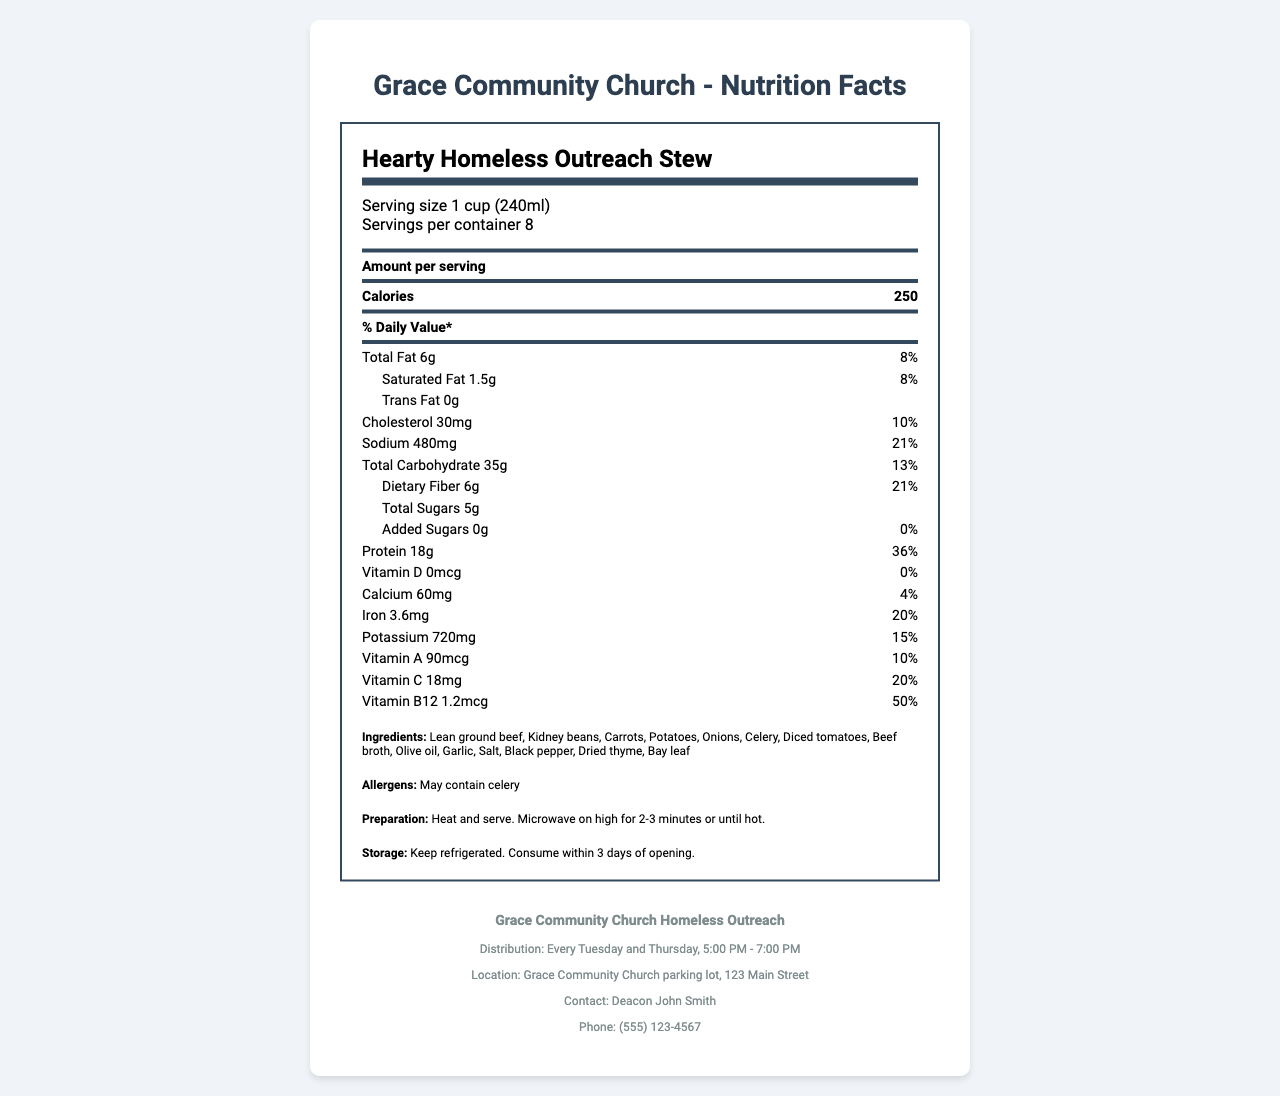how many servings are there per container? The serving info in the document states that there are 8 servings per container.
Answer: 8 what is the calorie content per serving? The document lists the calorie content of each serving as 250 calories.
Answer: 250 calories what percentage of daily value for protein is provided per serving? The document specifies that each serving provides 36% of the daily value for protein.
Answer: 36% how much dietary fiber is in each serving? The document states that each serving contains 6 grams of dietary fiber.
Answer: 6g what vitamins are prominently mentioned in the meal’s nutrient profile? The document highlights vitamins A, C, and B12 with their amounts and daily value percentages.
Answer: Vitamins A, C, and B12 how much cholesterol is in each serving? The document shows that there are 30 milligrams of cholesterol per serving.
Answer: 30mg which ingredient is specifically mentioned as a potential allergen? A. Garlic B. Celery C. Olive oil D. Carrots The allergens section of the document mentions that the meal may contain celery.
Answer: B. Celery when is the meal distribution for the outreach program? A. Monday and Wednesday B. Tuesday and Thursday C. Friday and Sunday The distribution schedule in the outreach program details section is every Tuesday and Thursday.
Answer: B. Tuesday and Thursday is the sodium content considered low for this meal? The sodium content is 480 mg per serving, which is 21% of the daily value, not considered low.
Answer: No does this meal include any added sugars? The document indicates that there are 0 grams of added sugars in the meal.
Answer: No summarize the nutritional benefits of the Hearty Homeless Outreach Stew and its intended purpose. This summary covers the key nutritional benefits, the ingredient choices, and the purpose behind creating the meal for individuals experiencing homelessness.
Answer: The Hearty Homeless Outreach Stew is designed to provide essential nutrients for individuals experiencing homelessness. It is high in protein (18g per serving, 36% daily value), dietary fiber (6g per serving, 21% daily value), and vitamins & minerals such as iron (20% DV), vitamin C (20% DV), and vitamin B12 (50% DV). Lean ground beef and kidney beans ensure good protein content, while a variety of vegetables contribute to the vitamin and mineral profile. The sodium content is managed to maintain a heart-healthy profile while ensuring palatability. what are the specific amounts listed for total sugars and added sugars? The document lists 5 grams of total sugars and 0 grams of added sugars per serving.
Answer: Total sugars: 5g, Added sugars: 0g what is the contact person's name for the outreach program? The outreach program details section lists Deacon John Smith as the contact person.
Answer: Deacon John Smith how much calcium is in each serving and what percentage of the daily value does it cover? Each serving contains 60 milligrams of calcium, which covers 4% of the daily value.
Answer: 60mg, 4% how should the meal be prepared according to the document? The preparation instructions specify to heat and serve the meal, recommending microwaving on high for 2-3 minutes or until hot.
Answer: Heat and serve. Microwave on high for 2-3 minutes or until hot. what is the name of the organization that prepared the meal? The document states that the meal is prepared by Grace Community Church.
Answer: Grace Community Church is the meal designed to help individuals with vitamin D deficiency? The meal contains 0 mcg of vitamin D, which is 0% of the daily value, indicating it is not designed to help with vitamin D deficiency.
Answer: No does the meal specifically cater to any dietary restrictions based on the ingredient list? While the meal contains various nutritious ingredients, it is not explicitly mentioned to cater to specific dietary restrictions other than containing celery as a potential allergen.
Answer: Not enough information where is the distribution location for the meal? The outreach program details mention that the meal is distributed at the Grace Community Church parking lot at 123 Main Street.
Answer: Grace Community Church parking lot, 123 Main Street 